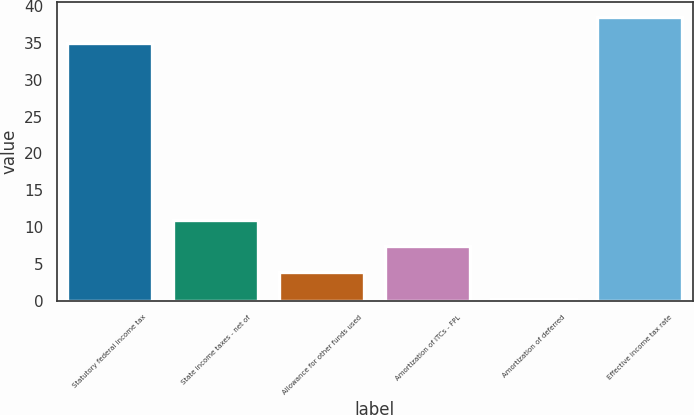<chart> <loc_0><loc_0><loc_500><loc_500><bar_chart><fcel>Statutory federal income tax<fcel>State income taxes - net of<fcel>Allowance for other funds used<fcel>Amortization of ITCs - FPL<fcel>Amortization of deferred<fcel>Effective income tax rate<nl><fcel>35<fcel>10.98<fcel>3.86<fcel>7.42<fcel>0.3<fcel>38.56<nl></chart> 